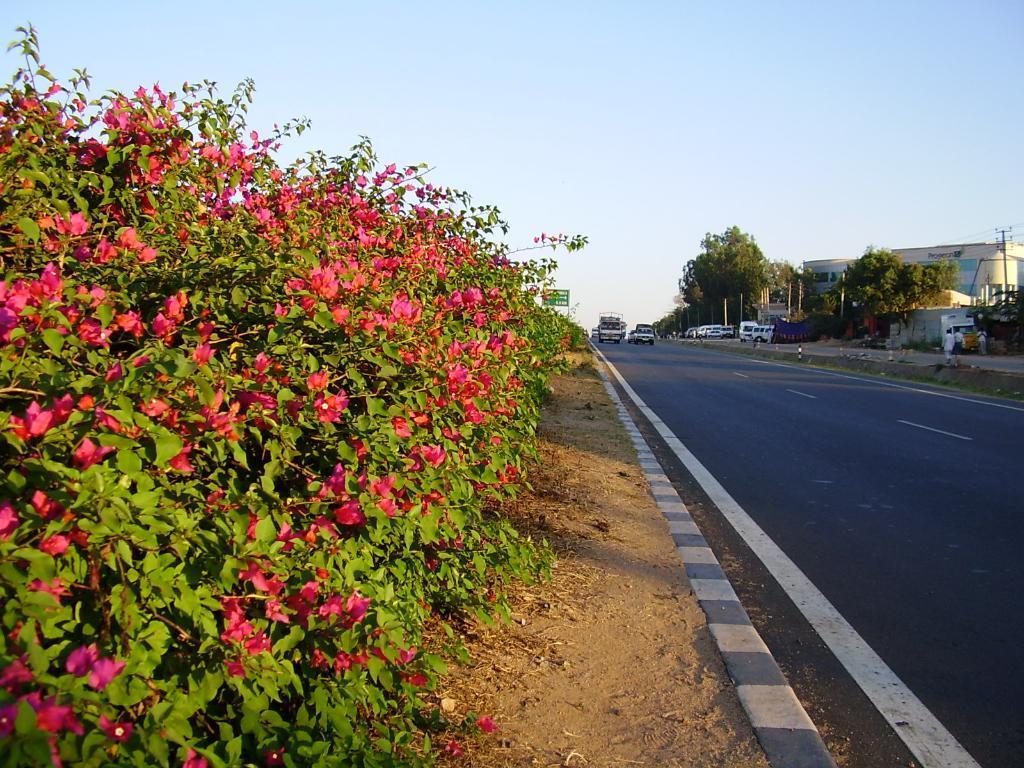Describe this image in one or two sentences. In this image we can see many trees. We can also see a pink color flower plant. Image also consists of many vehicles. At the top there is sky. Buildings and road is also visible in this image. 